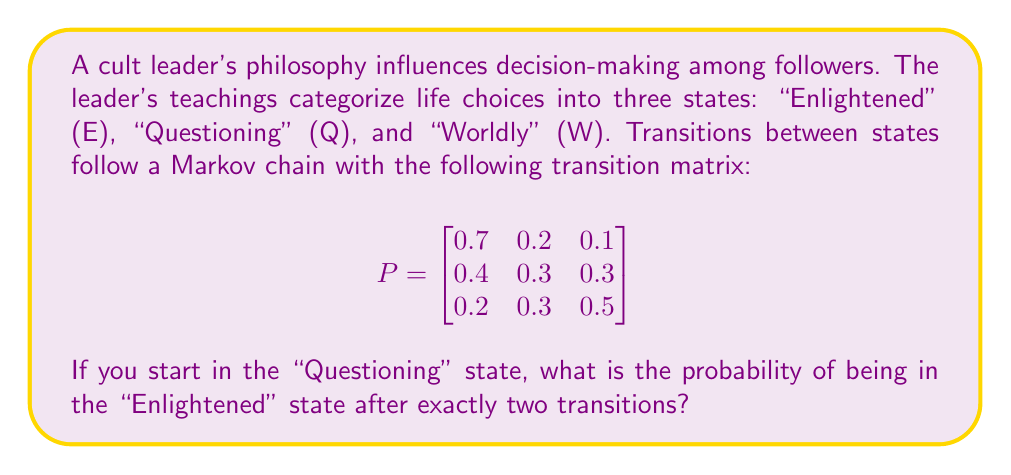Give your solution to this math problem. To solve this problem, we need to use the properties of Markov chains and matrix multiplication. Let's break it down step-by-step:

1) The initial state is "Questioning" (Q), which corresponds to the second row of the transition matrix.

2) We need to find the probability of being in the "Enlightened" (E) state after two transitions, which corresponds to the first column of the resulting matrix.

3) To find the probabilities after two transitions, we need to multiply the transition matrix by itself:

   $$P^2 = P \times P = \begin{bmatrix}
   0.7 & 0.2 & 0.1 \\
   0.4 & 0.3 & 0.3 \\
   0.2 & 0.3 & 0.5
   \end{bmatrix} \times \begin{bmatrix}
   0.7 & 0.2 & 0.1 \\
   0.4 & 0.3 & 0.3 \\
   0.2 & 0.3 & 0.5
   \end{bmatrix}$$

4) Performing the matrix multiplication:

   $$P^2 = \begin{bmatrix}
   0.59 & 0.23 & 0.18 \\
   0.46 & 0.27 & 0.27 \\
   0.35 & 0.29 & 0.36
   \end{bmatrix}$$

5) Since we start in the "Questioning" state (second row) and want to end in the "Enlightened" state (first column), the probability we're looking for is the element in the second row, first column of $P^2$.

Therefore, the probability of being in the "Enlightened" state after exactly two transitions, starting from the "Questioning" state, is 0.46 or 46%.
Answer: 0.46 